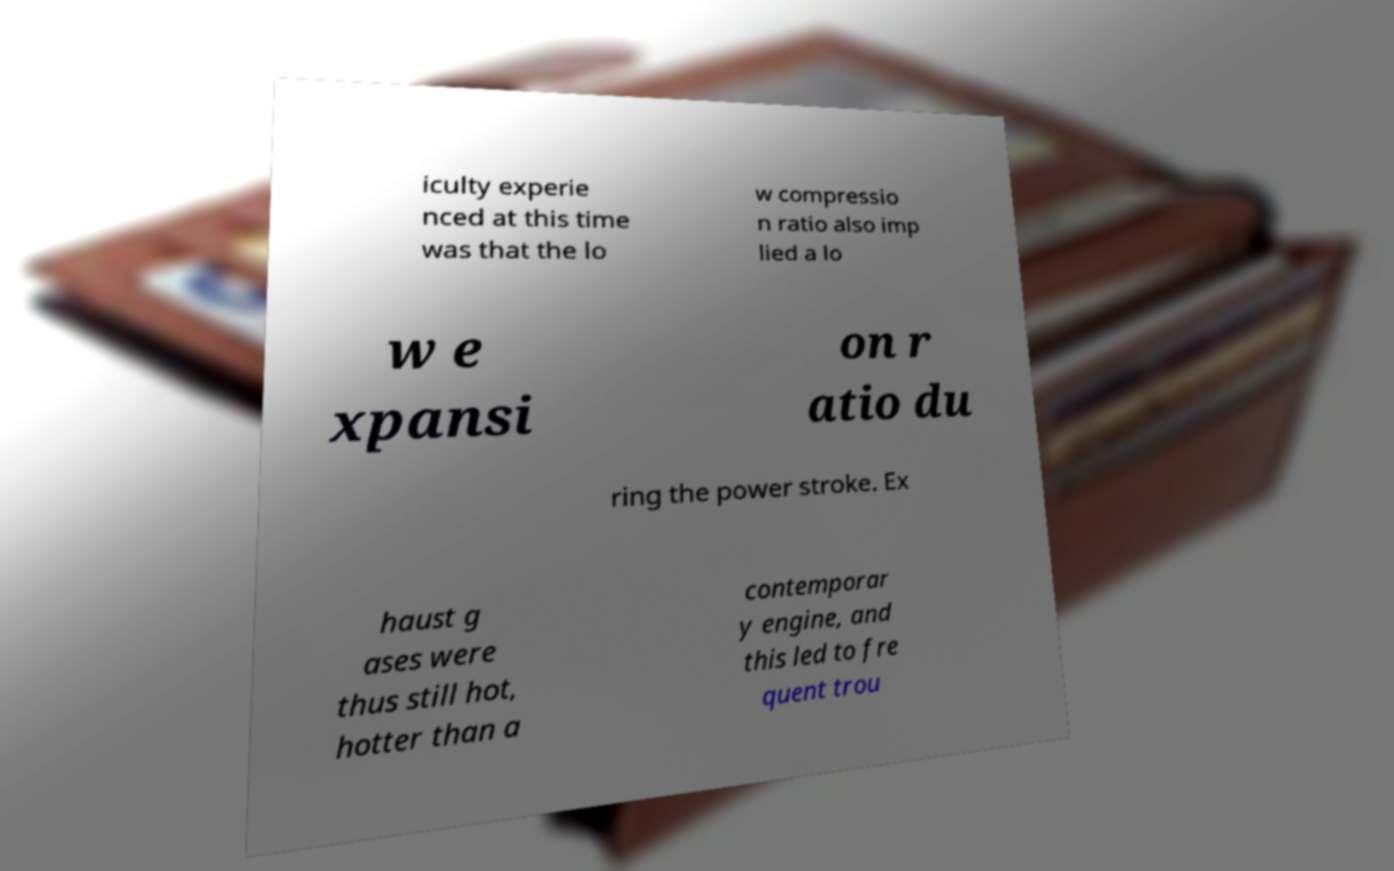I need the written content from this picture converted into text. Can you do that? iculty experie nced at this time was that the lo w compressio n ratio also imp lied a lo w e xpansi on r atio du ring the power stroke. Ex haust g ases were thus still hot, hotter than a contemporar y engine, and this led to fre quent trou 